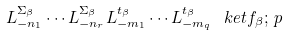<formula> <loc_0><loc_0><loc_500><loc_500>L _ { - n _ { 1 } } ^ { \Sigma _ { \beta } } \cdots L _ { - n _ { r } } ^ { \Sigma _ { \beta } } L ^ { t _ { \beta } } _ { - m _ { 1 } } \cdots L ^ { t _ { \beta } } _ { - m _ { q } } \ k e t { f _ { \beta } ; \, p }</formula> 